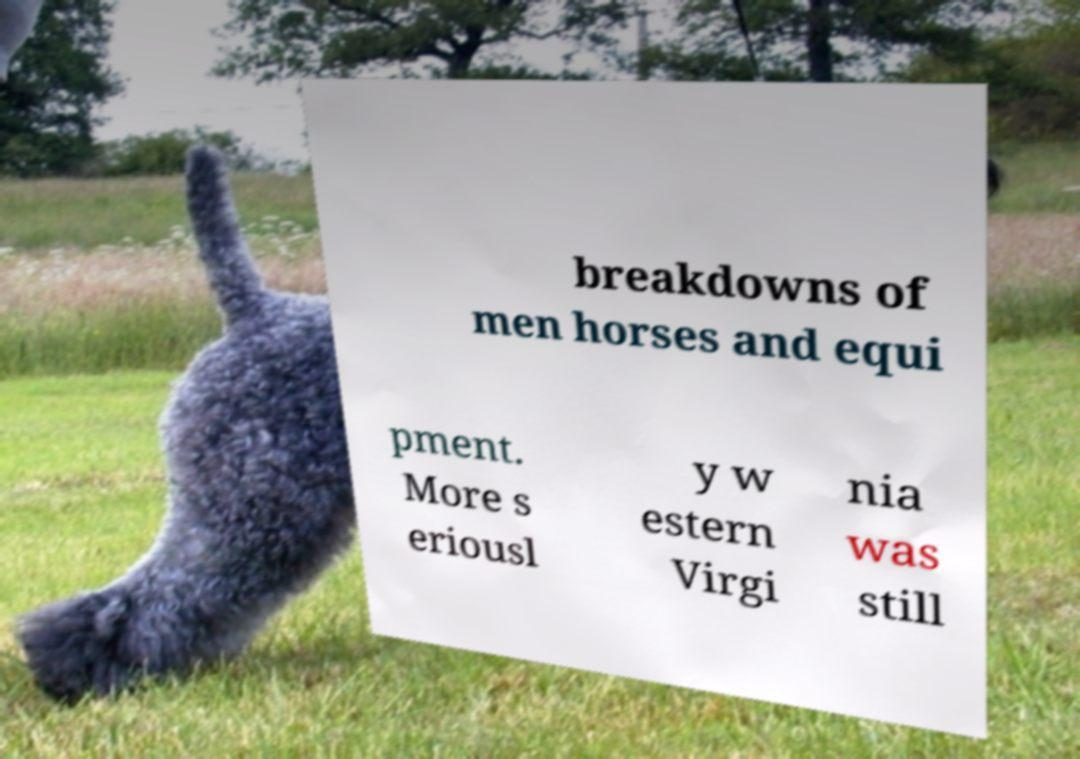There's text embedded in this image that I need extracted. Can you transcribe it verbatim? breakdowns of men horses and equi pment. More s eriousl y w estern Virgi nia was still 